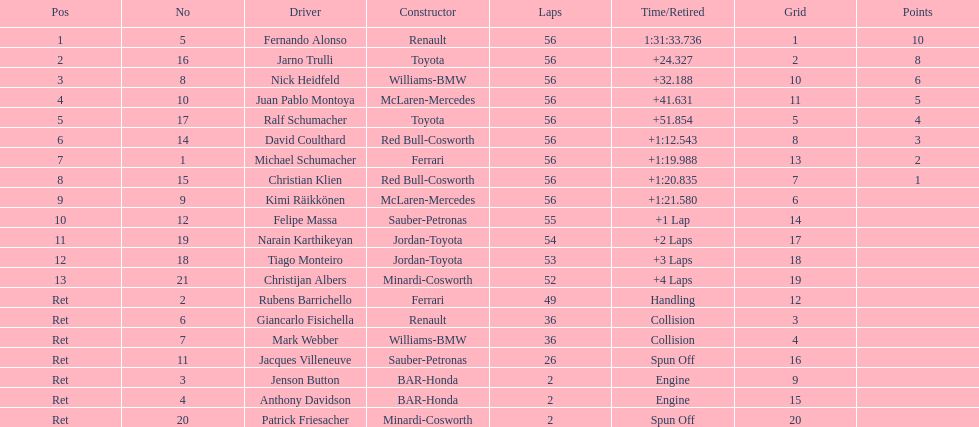Who was the last driver from the uk to actually finish the 56 laps? David Coulthard. 